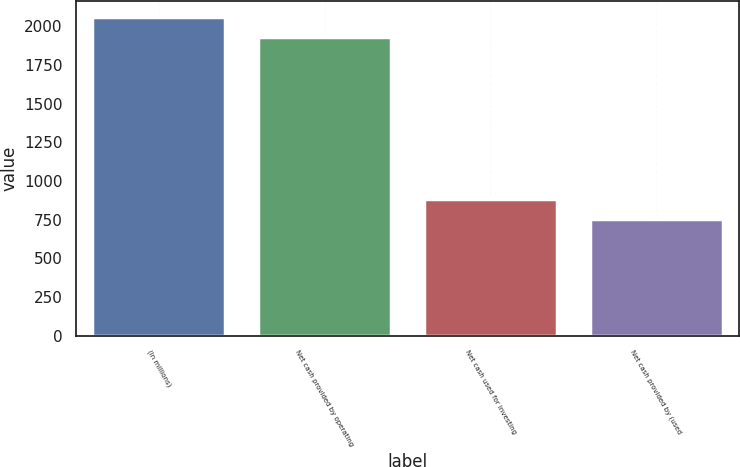<chart> <loc_0><loc_0><loc_500><loc_500><bar_chart><fcel>(In millions)<fcel>Net cash provided by operating<fcel>Net cash used for investing<fcel>Net cash provided by (used<nl><fcel>2057.49<fcel>1931.2<fcel>881.39<fcel>755.1<nl></chart> 